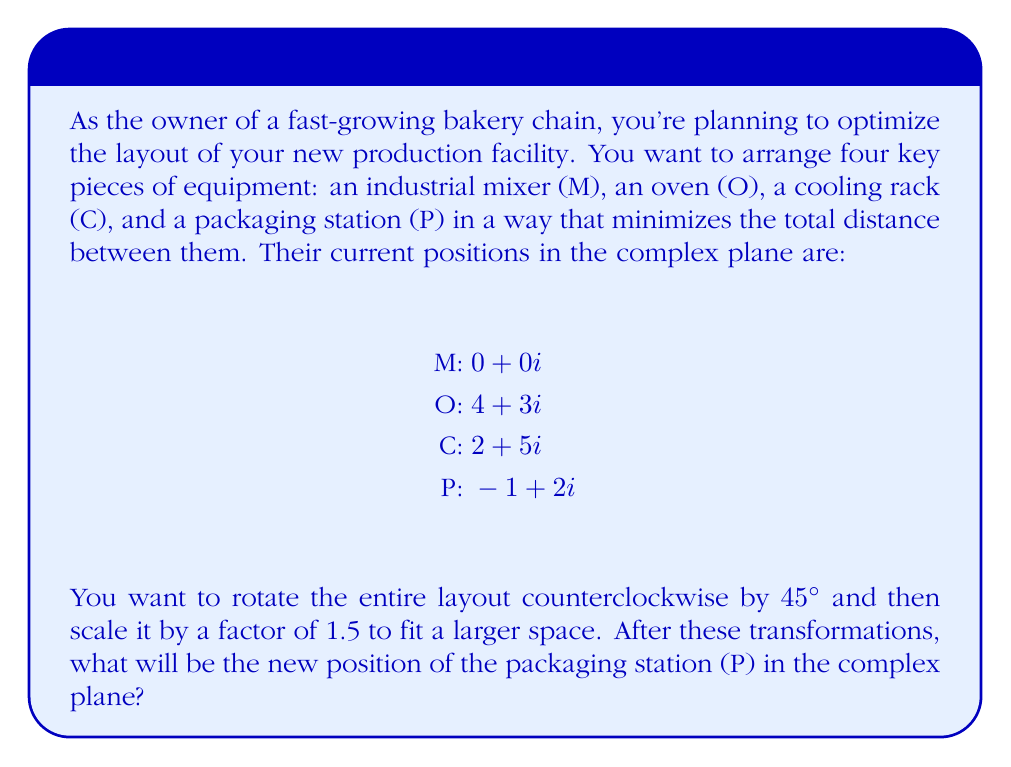What is the answer to this math problem? To solve this problem, we'll apply complex plane transformations in the following steps:

1) First, let's recall that rotation by an angle $\theta$ counterclockwise is achieved by multiplying the complex number by $e^{i\theta}$. For 45°, $\theta = \frac{\pi}{4}$.

2) Scaling by a factor $k$ is done by multiplying the complex number by $k$.

3) Therefore, our transformation can be represented as: $z_{new} = 1.5 \cdot e^{i\frac{\pi}{4}} \cdot z_{old}$

4) We need to calculate $e^{i\frac{\pi}{4}}$:
   
   $e^{i\frac{\pi}{4}} = \cos(\frac{\pi}{4}) + i\sin(\frac{\pi}{4}) = \frac{\sqrt{2}}{2} + i\frac{\sqrt{2}}{2}$

5) Now, let's apply the transformation to the packaging station (P):

   $z_{old} = -1 + 2i$
   
   $z_{new} = 1.5 \cdot (\frac{\sqrt{2}}{2} + i\frac{\sqrt{2}}{2}) \cdot (-1 + 2i)$

6) Let's multiply the complex numbers:
   
   $(\frac{\sqrt{2}}{2} + i\frac{\sqrt{2}}{2}) \cdot (-1 + 2i) = (-\frac{\sqrt{2}}{2} - \frac{\sqrt{2}}{2}) + (\frac{\sqrt{2}}{2} - \frac{\sqrt{2}}{2})i = -\sqrt{2}$

7) Finally, we multiply by 1.5:
   
   $z_{new} = 1.5 \cdot (-\sqrt{2}) = -1.5\sqrt{2}$

8) To express this in $a + bi$ form, we can approximate:
   
   $z_{new} \approx -2.12 + 0i$
Answer: The new position of the packaging station (P) after the transformations is approximately $-2.12 + 0i$ in the complex plane. 